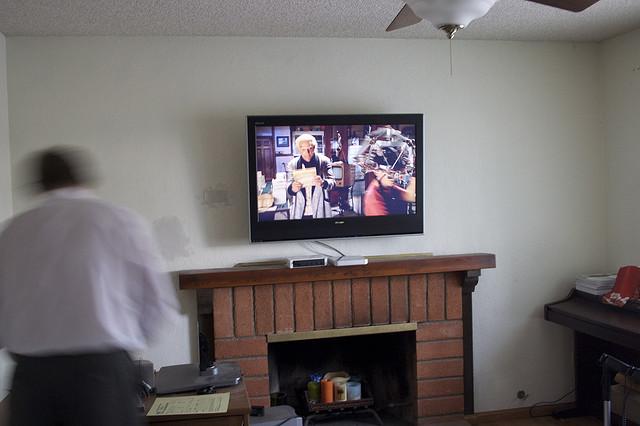What is inside of the fireplace?
Concise answer only. Candles. Is this a real person?
Keep it brief. Yes. Is the TV on or off?
Give a very brief answer. On. What movie are they watching?
Quick response, please. Back to future. How many animals are on the TV screen?
Write a very short answer. 0. What type of stone is used in the chimney area?
Write a very short answer. Brick. Is this man wearing a jacket?
Concise answer only. No. What material is the fireplace made out of?
Quick response, please. Brick. What room is this?
Concise answer only. Living room. Is the fireplace lit?
Concise answer only. No. What does it appear that the man on the television is looking at in the room?
Be succinct. Paper. Is everything in focus?
Concise answer only. No. What color is the wall?
Be succinct. White. Are there people in the picture?
Give a very brief answer. Yes. What are on the wall?
Write a very short answer. Tv. Is the fireplace in use?
Be succinct. No. Who is in the room?
Short answer required. Man. 